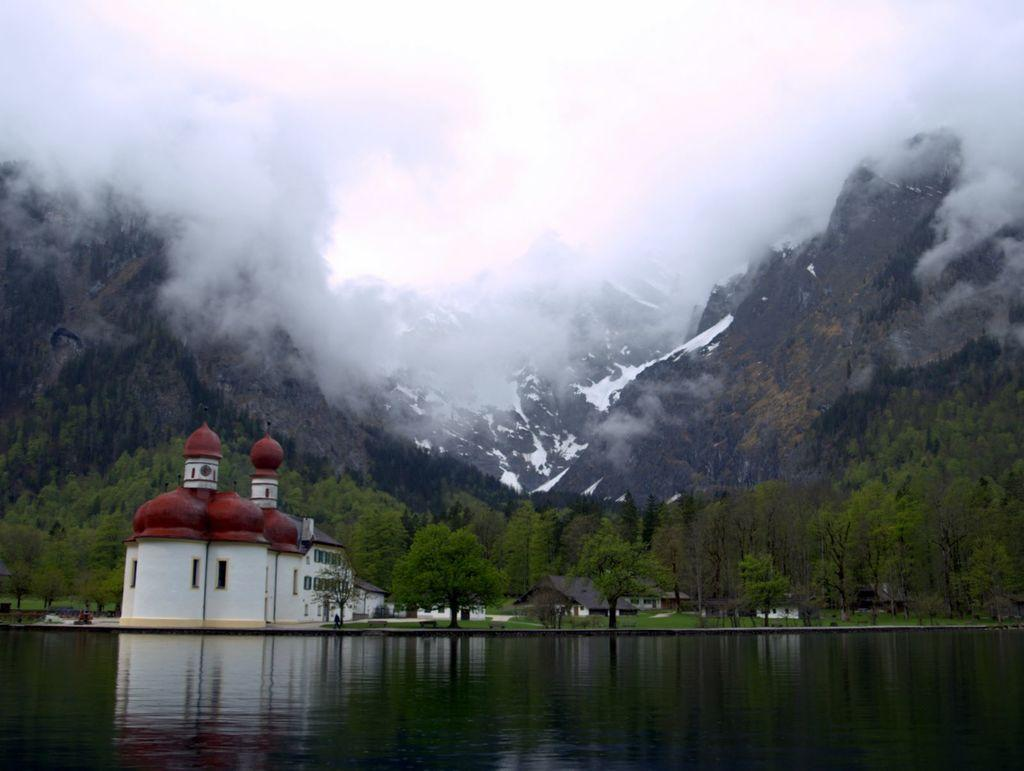What types of structures are present in the image? There are buildings and houses in the image. What feature do the buildings and houses have in common? The buildings and houses have roofs. What natural feature is located near the structures? The structures are near a water body. What type of vegetation can be seen in the image? There is a group of trees in the image. What geographical feature is visible in the image? The hills are visible in the image. How would you describe the weather based on the image? The sky appears cloudy in the image. What type of fear can be seen on the ghost's face in the image? There is no ghost present in the image, so it is not possible to determine the fear on its face. 